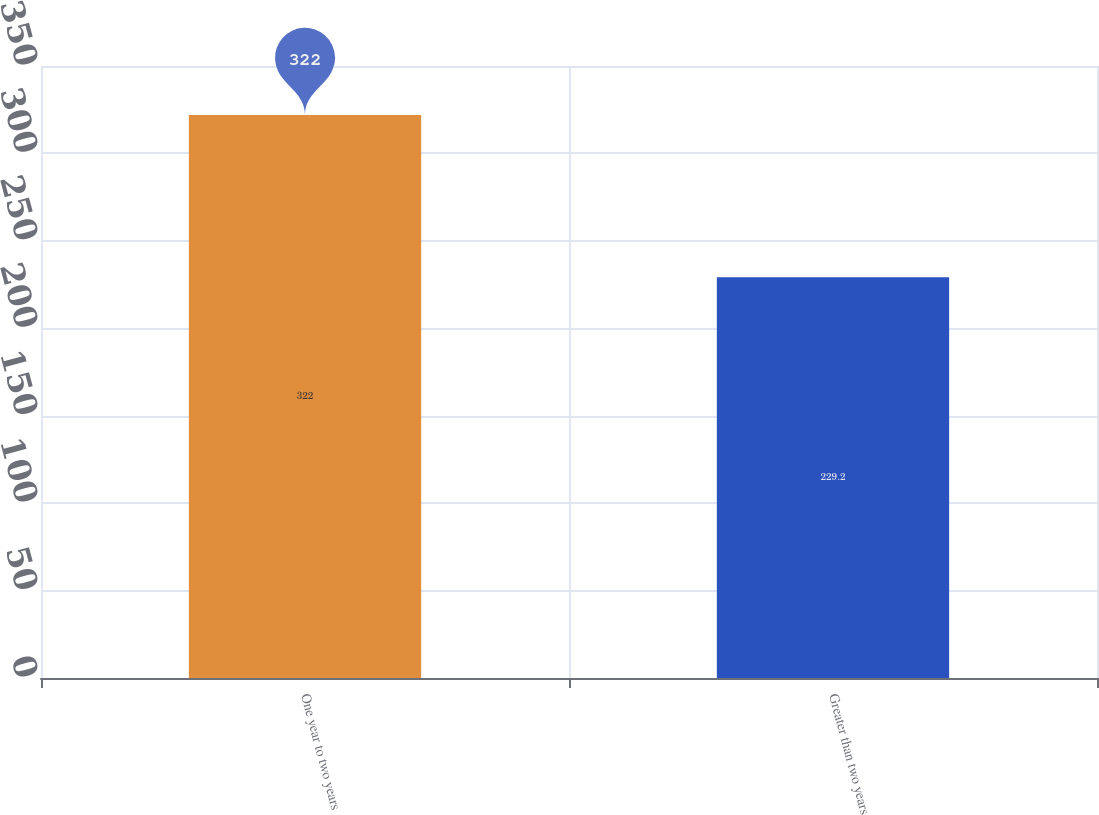<chart> <loc_0><loc_0><loc_500><loc_500><bar_chart><fcel>One year to two years<fcel>Greater than two years<nl><fcel>322<fcel>229.2<nl></chart> 